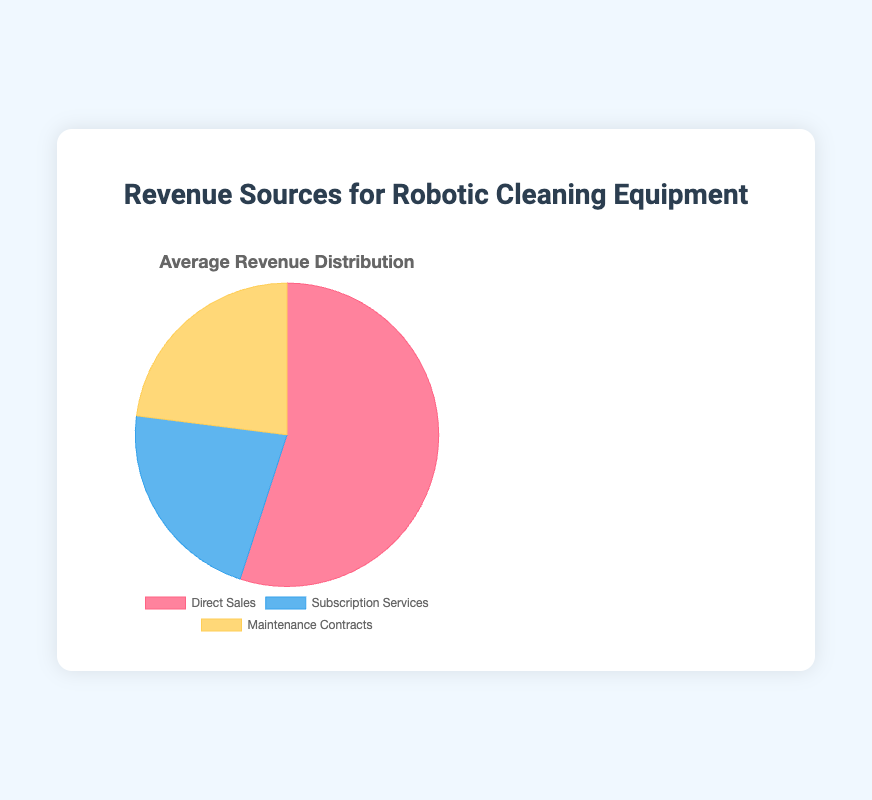What is the largest source of revenue according to the pie chart? The pie chart shows that Direct Sales occupies the largest segment of the pie, making it the largest source of revenue.
Answer: Direct Sales Which two revenue sources are approximately equal in terms of percentage? According to the pie chart, Subscription Services and Maintenance Contracts have similar percentages, represented by nearly equal-sized segments.
Answer: Subscription Services and Maintenance Contracts What percentage of revenue comes from Maintenance Contracts? From the pie chart, it is indicated that the segment for Maintenance Contracts is 23%.
Answer: 23% How does the percentage of revenue from Direct Sales compare to Subscription Services? The percentage of revenue from Direct Sales is 55%, which is more than double the 22% from Subscription Services, as the pie chart shows.
Answer: Direct Sales is more than double Subscription Services If you add the revenue percentages for Subscription Services and Maintenance Contracts, what is the total? According to the pie chart, Subscription Services contribute 22% and Maintenance Contracts contribute 23%. Adding them gives a total of 22% + 23% = 45%.
Answer: 45% Which color represents the highest revenue source in the pie chart? The pie chart uses colors to represent different categories, and the largest segment (Direct Sales at 55%) is colored red.
Answer: Red Compare the total percentage of revenue from non-sales sources (Subscription Services and Maintenance Contracts) to Direct Sales. The non-sales sources (Subscription Services and Maintenance Contracts) have a combined total of 22% + 23% = 45%. Direct Sales alone is 55%. Therefore, Direct Sales is higher than the combined non-sales sources.
Answer: Direct Sales is higher What is the average percentage of revenue for Subscription Services and Maintenance Contracts? To find the average, sum the percentages of Subscription Services (22%) and Maintenance Contracts (23%) and divide by 2: (22% + 23%) / 2 = 22.5%.
Answer: 22.5% 